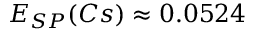Convert formula to latex. <formula><loc_0><loc_0><loc_500><loc_500>E _ { S P } ( C s ) \approx 0 . 0 5 2 4</formula> 